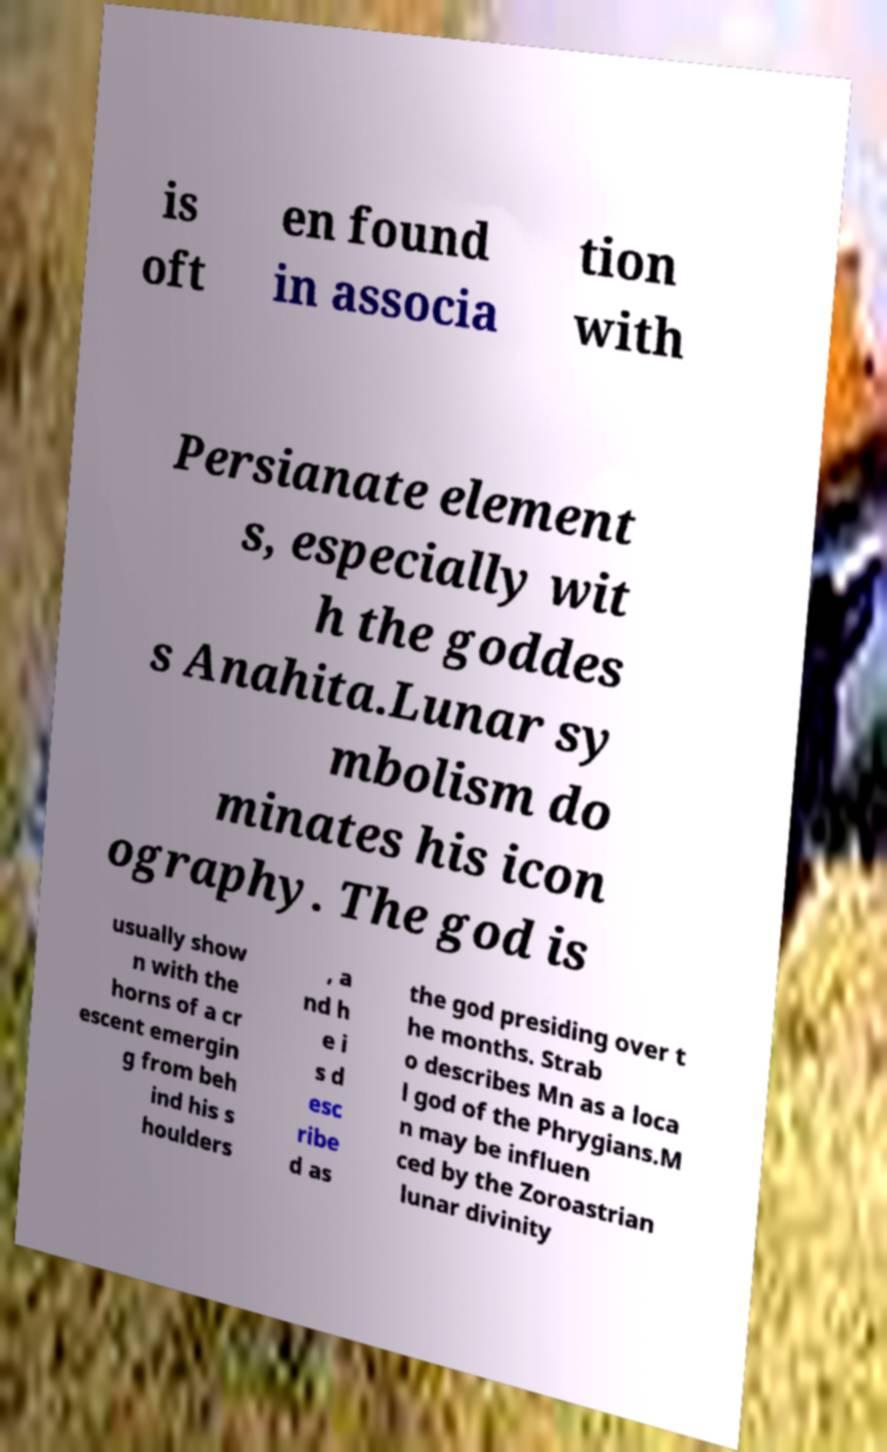Could you extract and type out the text from this image? is oft en found in associa tion with Persianate element s, especially wit h the goddes s Anahita.Lunar sy mbolism do minates his icon ography. The god is usually show n with the horns of a cr escent emergin g from beh ind his s houlders , a nd h e i s d esc ribe d as the god presiding over t he months. Strab o describes Mn as a loca l god of the Phrygians.M n may be influen ced by the Zoroastrian lunar divinity 